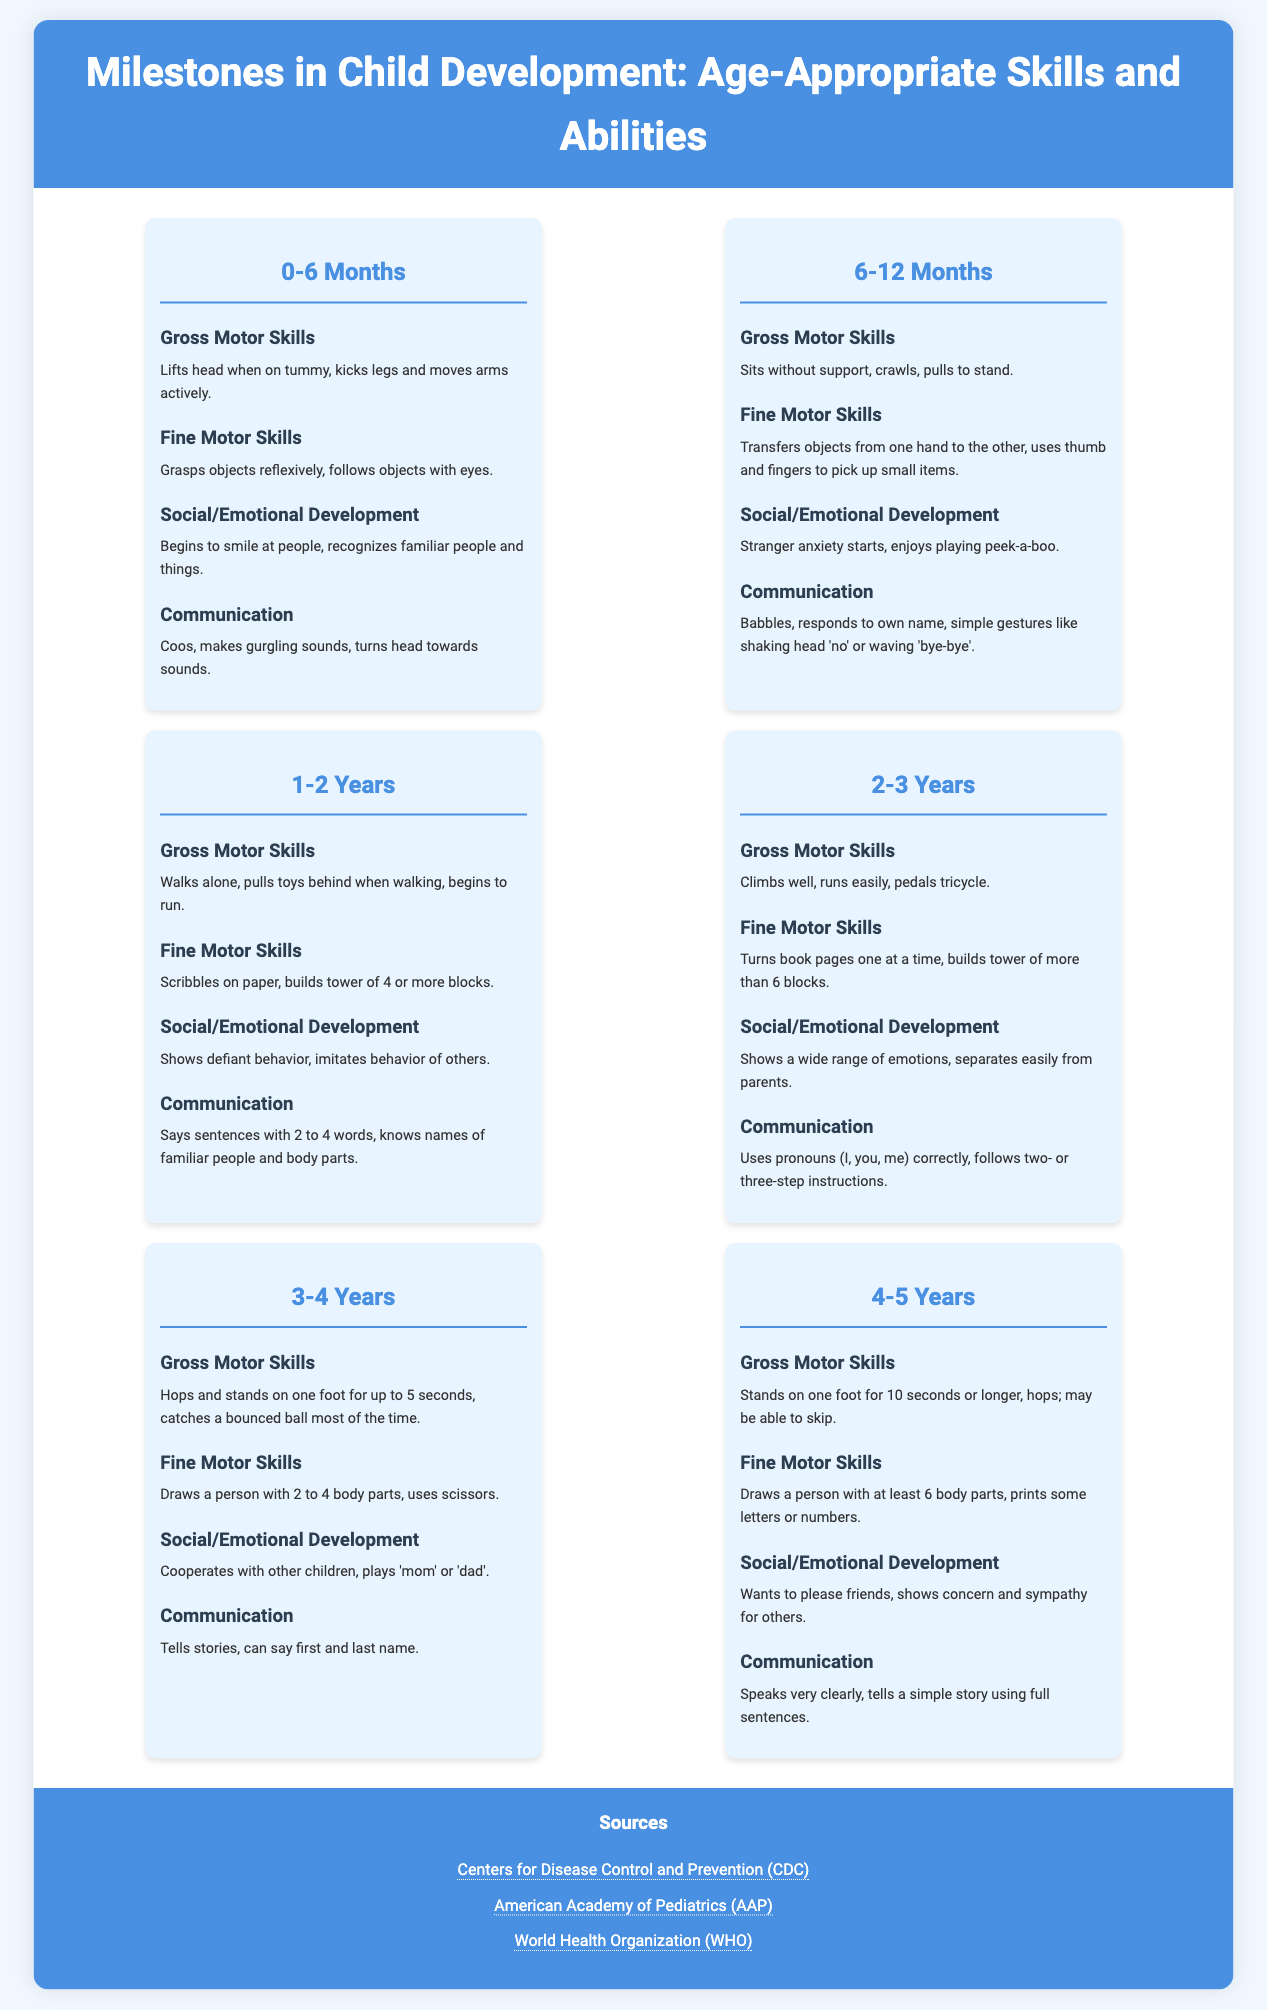What is the title of the infographic? The title of the infographic is prominently displayed at the top of the document.
Answer: Milestones in Child Development: Age-Appropriate Skills and Abilities What age group is covered in the second section? The second section of the infographic details milestones for children aged 6-12 months.
Answer: 6-12 Months How many body parts can a child draw at 3-4 years? The milestones for 3-4 years specify that a child can draw a person with 2 to 4 body parts.
Answer: 2 to 4 body parts What gross motor skill is developed at 4-5 years? The infographic lists that children at this age can stand on one foot for 10 seconds or longer as a gross motor skill.
Answer: Stands on one foot for 10 seconds or longer Which organization is cited as a source for this infographic? The sources section lists several organizations, indicating credibility and where to find more information.
Answer: Centers for Disease Control and Prevention (CDC) How does a child begin to communicate at 0-6 months? Communication milestones for this age indicate that infants coo and make gurgling sounds.
Answer: Coos, makes gurgling sounds What action signifies social/emotional development in 1-2 years? The milestone specifies that children at this age show defiant behavior, indicating emotional growth.
Answer: Shows defiant behavior How many blocks can a child build as a fine motor skill at 2-3 years? In the milestones for 2-3 years, it's noted that a child can build a tower of more than 6 blocks.
Answer: More than 6 blocks What is the primary source for early child development guidelines? The cited sources include multiple reputable organizations focusing on child development.
Answer: World Health Organization (WHO) 